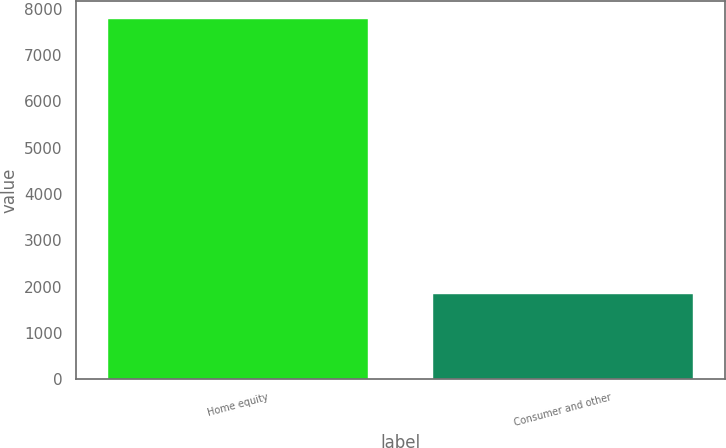Convert chart to OTSL. <chart><loc_0><loc_0><loc_500><loc_500><bar_chart><fcel>Home equity<fcel>Consumer and other<nl><fcel>7769.7<fcel>1841.3<nl></chart> 